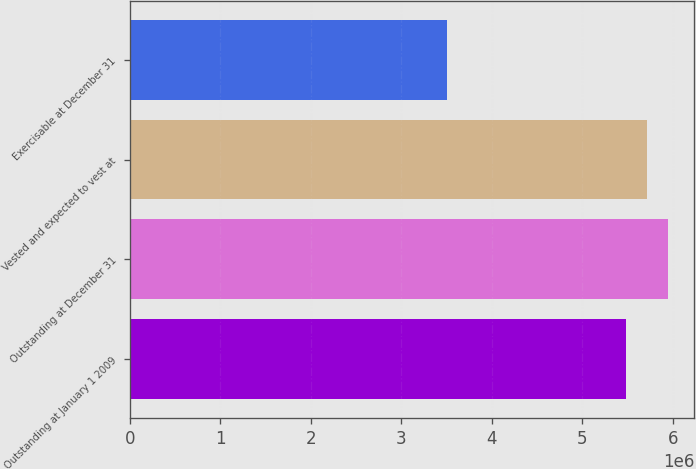Convert chart to OTSL. <chart><loc_0><loc_0><loc_500><loc_500><bar_chart><fcel>Outstanding at January 1 2009<fcel>Outstanding at December 31<fcel>Vested and expected to vest at<fcel>Exercisable at December 31<nl><fcel>5.4859e+06<fcel>5.94433e+06<fcel>5.71512e+06<fcel>3.50084e+06<nl></chart> 